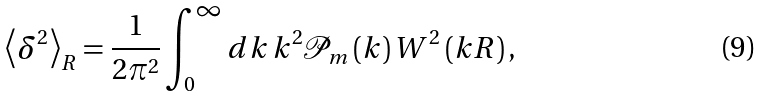<formula> <loc_0><loc_0><loc_500><loc_500>\left \langle \delta ^ { 2 } \right \rangle _ { R } = \frac { 1 } { 2 \pi ^ { 2 } } \int _ { 0 } ^ { \infty } d k \, k ^ { 2 } \mathcal { P } _ { m } \left ( k \right ) W ^ { 2 } \left ( k R \right ) ,</formula> 